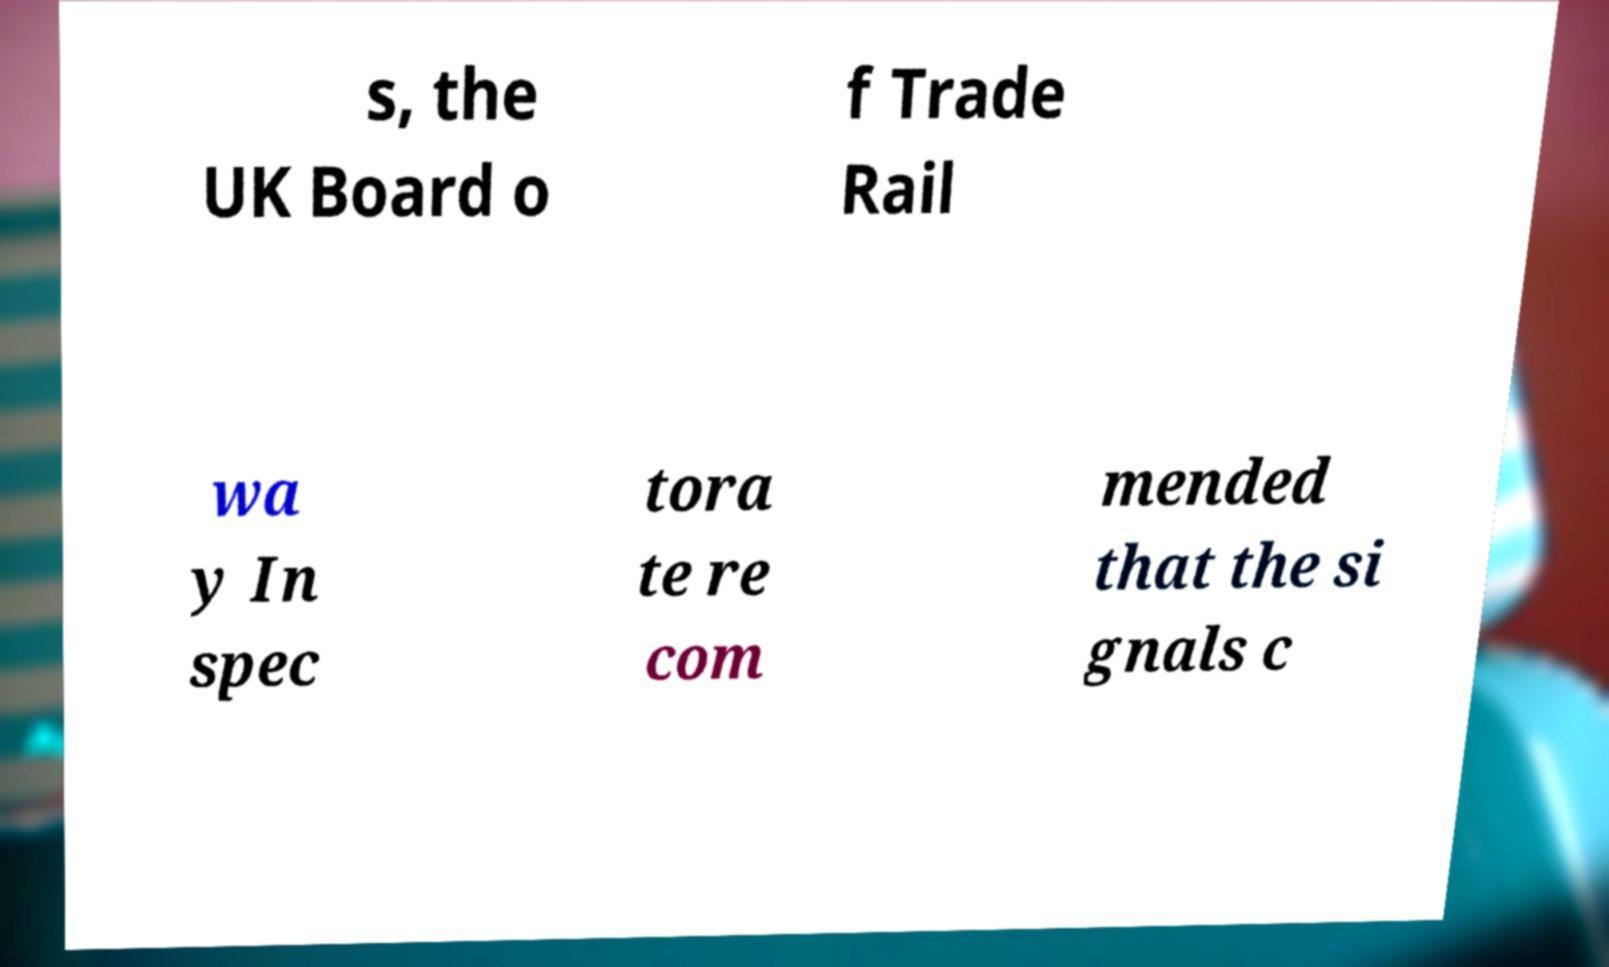What messages or text are displayed in this image? I need them in a readable, typed format. s, the UK Board o f Trade Rail wa y In spec tora te re com mended that the si gnals c 